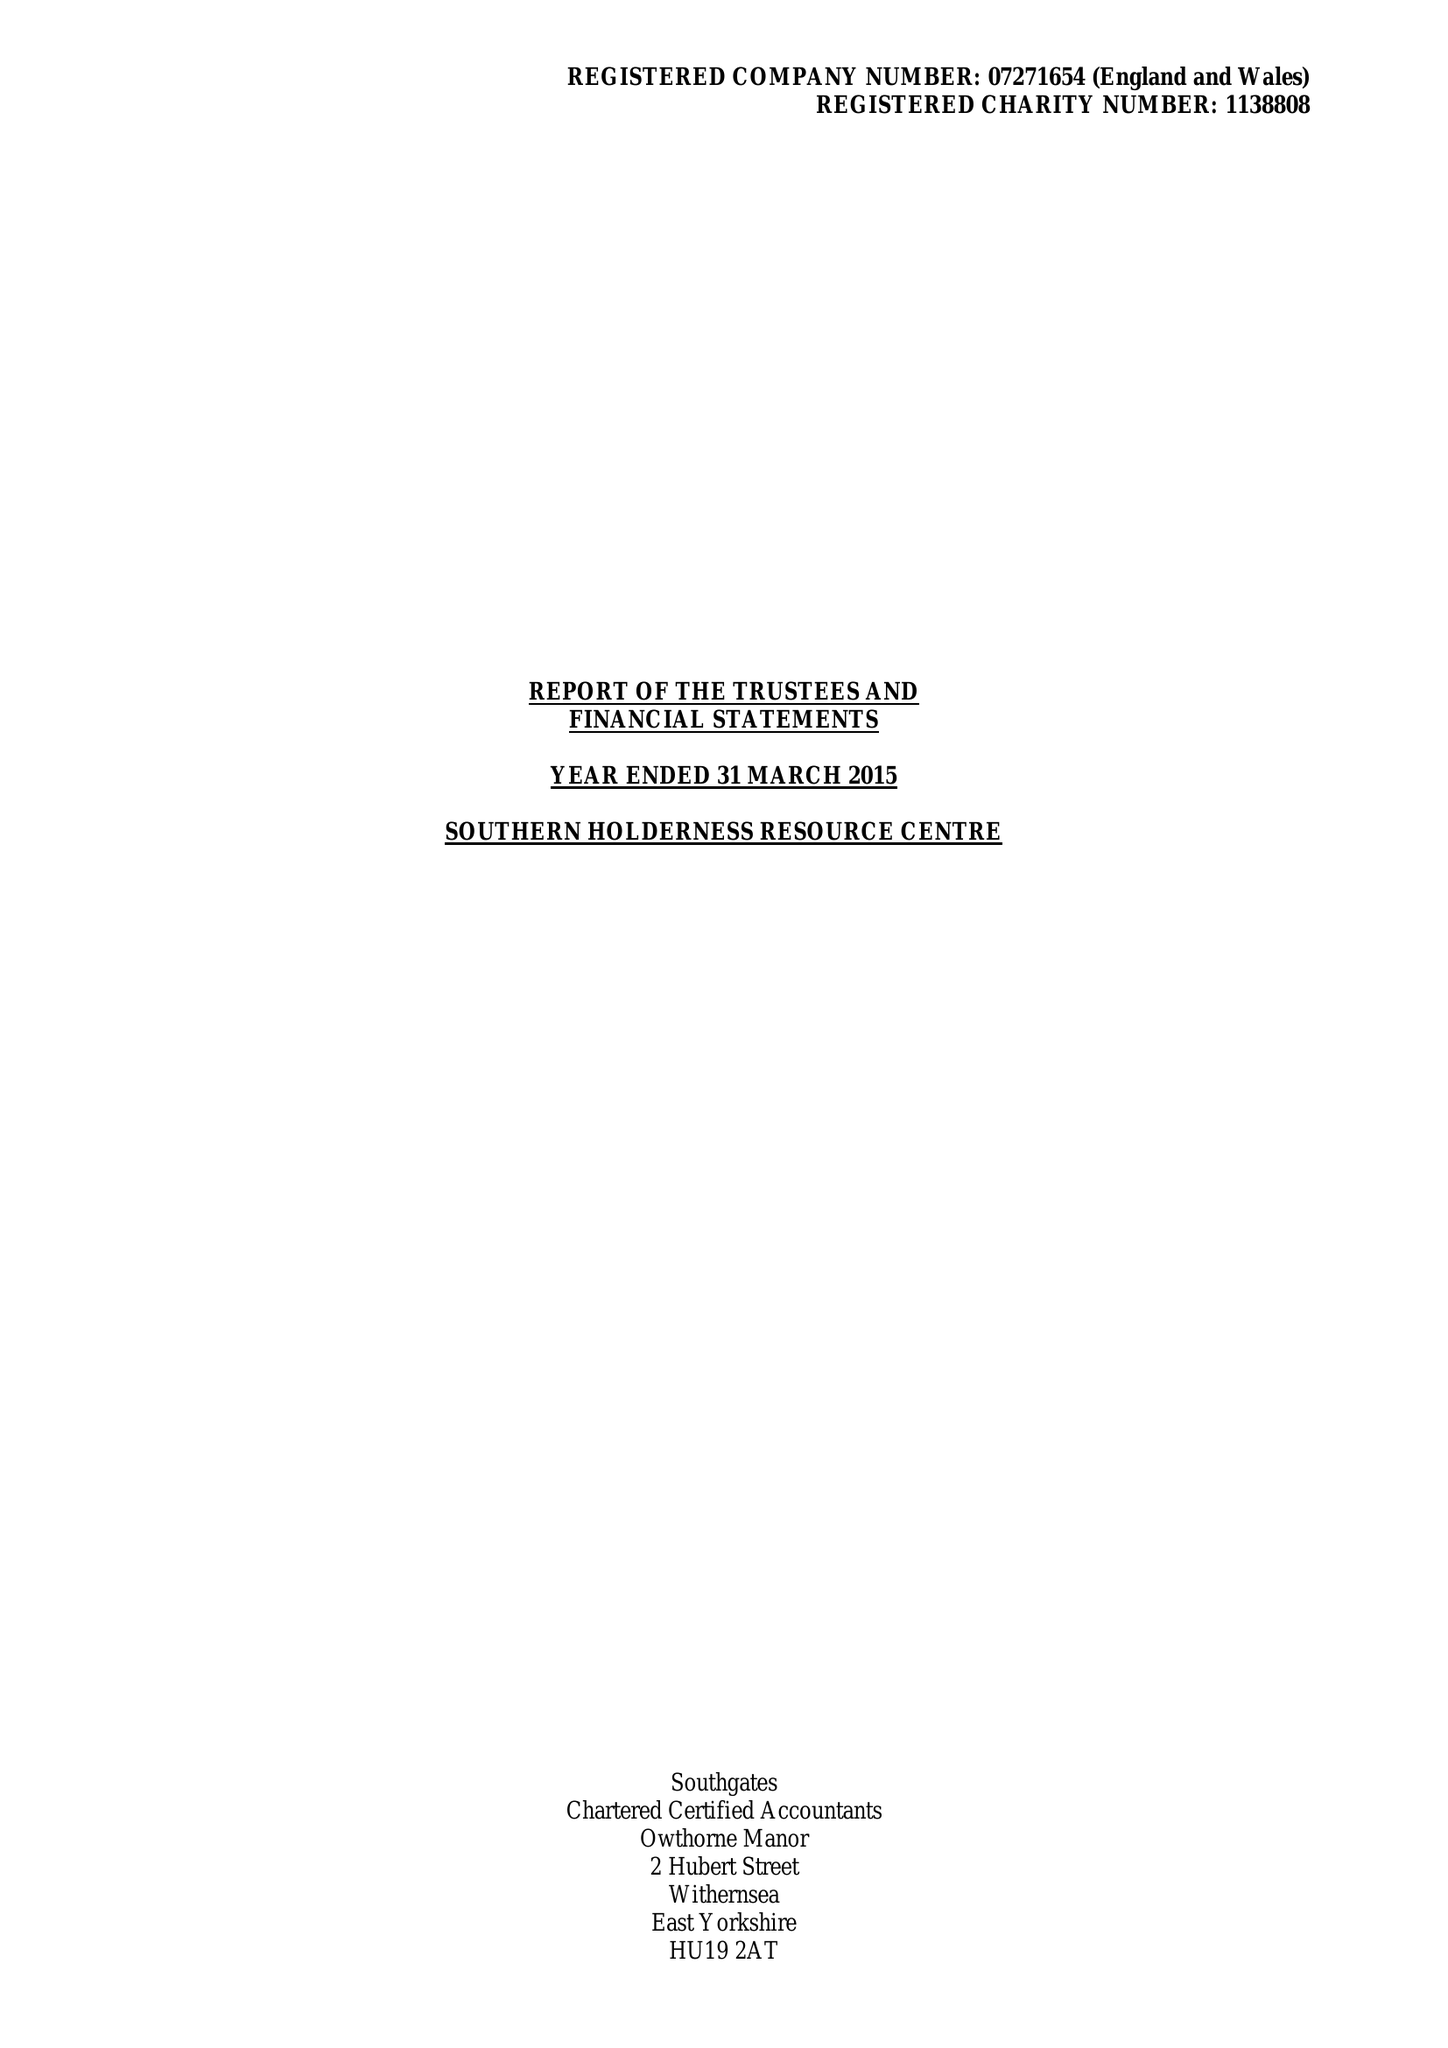What is the value for the spending_annually_in_british_pounds?
Answer the question using a single word or phrase. 355960.00 